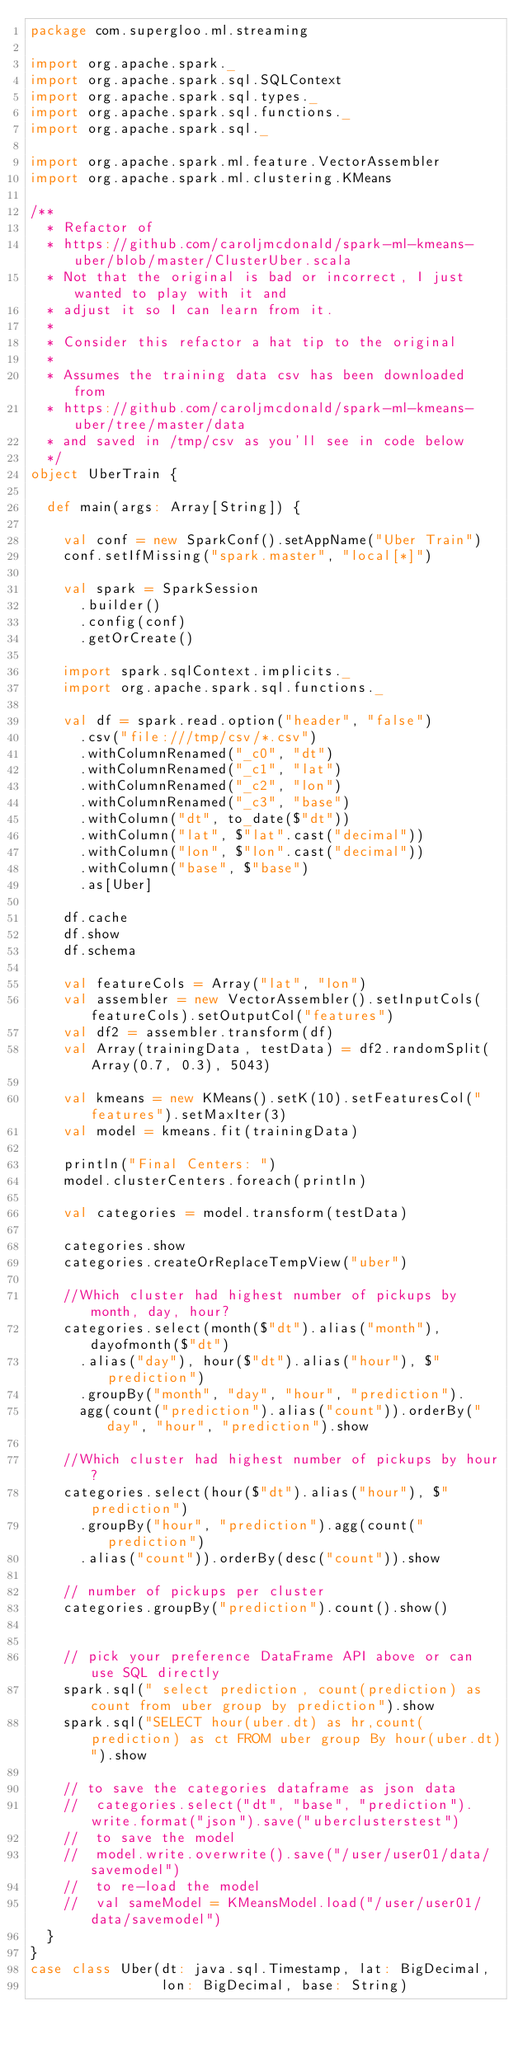<code> <loc_0><loc_0><loc_500><loc_500><_Scala_>package com.supergloo.ml.streaming

import org.apache.spark._
import org.apache.spark.sql.SQLContext
import org.apache.spark.sql.types._
import org.apache.spark.sql.functions._
import org.apache.spark.sql._

import org.apache.spark.ml.feature.VectorAssembler
import org.apache.spark.ml.clustering.KMeans

/**
  * Refactor of
  * https://github.com/caroljmcdonald/spark-ml-kmeans-uber/blob/master/ClusterUber.scala
  * Not that the original is bad or incorrect, I just wanted to play with it and
  * adjust it so I can learn from it.
  *
  * Consider this refactor a hat tip to the original
  *
  * Assumes the training data csv has been downloaded from
  * https://github.com/caroljmcdonald/spark-ml-kmeans-uber/tree/master/data
  * and saved in /tmp/csv as you'll see in code below
  */
object UberTrain {

  def main(args: Array[String]) {

    val conf = new SparkConf().setAppName("Uber Train")
    conf.setIfMissing("spark.master", "local[*]")

    val spark = SparkSession
      .builder()
      .config(conf)
      .getOrCreate()

    import spark.sqlContext.implicits._
    import org.apache.spark.sql.functions._

    val df = spark.read.option("header", "false")
      .csv("file:///tmp/csv/*.csv")
      .withColumnRenamed("_c0", "dt")
      .withColumnRenamed("_c1", "lat")
      .withColumnRenamed("_c2", "lon")
      .withColumnRenamed("_c3", "base")
      .withColumn("dt", to_date($"dt"))
      .withColumn("lat", $"lat".cast("decimal"))
      .withColumn("lon", $"lon".cast("decimal"))
      .withColumn("base", $"base")
      .as[Uber]

    df.cache
    df.show
    df.schema

    val featureCols = Array("lat", "lon")
    val assembler = new VectorAssembler().setInputCols(featureCols).setOutputCol("features")
    val df2 = assembler.transform(df)
    val Array(trainingData, testData) = df2.randomSplit(Array(0.7, 0.3), 5043)

    val kmeans = new KMeans().setK(10).setFeaturesCol("features").setMaxIter(3)
    val model = kmeans.fit(trainingData)

    println("Final Centers: ")
    model.clusterCenters.foreach(println)

    val categories = model.transform(testData)

    categories.show
    categories.createOrReplaceTempView("uber")

    //Which cluster had highest number of pickups by month, day, hour?
    categories.select(month($"dt").alias("month"), dayofmonth($"dt")
      .alias("day"), hour($"dt").alias("hour"), $"prediction")
      .groupBy("month", "day", "hour", "prediction").
      agg(count("prediction").alias("count")).orderBy("day", "hour", "prediction").show

    //Which cluster had highest number of pickups by hour?
    categories.select(hour($"dt").alias("hour"), $"prediction")
      .groupBy("hour", "prediction").agg(count("prediction")
      .alias("count")).orderBy(desc("count")).show

    // number of pickups per cluster
    categories.groupBy("prediction").count().show()


    // pick your preference DataFrame API above or can use SQL directly
    spark.sql(" select prediction, count(prediction) as count from uber group by prediction").show
    spark.sql("SELECT hour(uber.dt) as hr,count(prediction) as ct FROM uber group By hour(uber.dt)").show

    // to save the categories dataframe as json data
    //  categories.select("dt", "base", "prediction").write.format("json").save("uberclusterstest")
    //  to save the model
    //  model.write.overwrite().save("/user/user01/data/savemodel")
    //  to re-load the model
    //  val sameModel = KMeansModel.load("/user/user01/data/savemodel")
  }
}
case class Uber(dt: java.sql.Timestamp, lat: BigDecimal,
                lon: BigDecimal, base: String)
</code> 